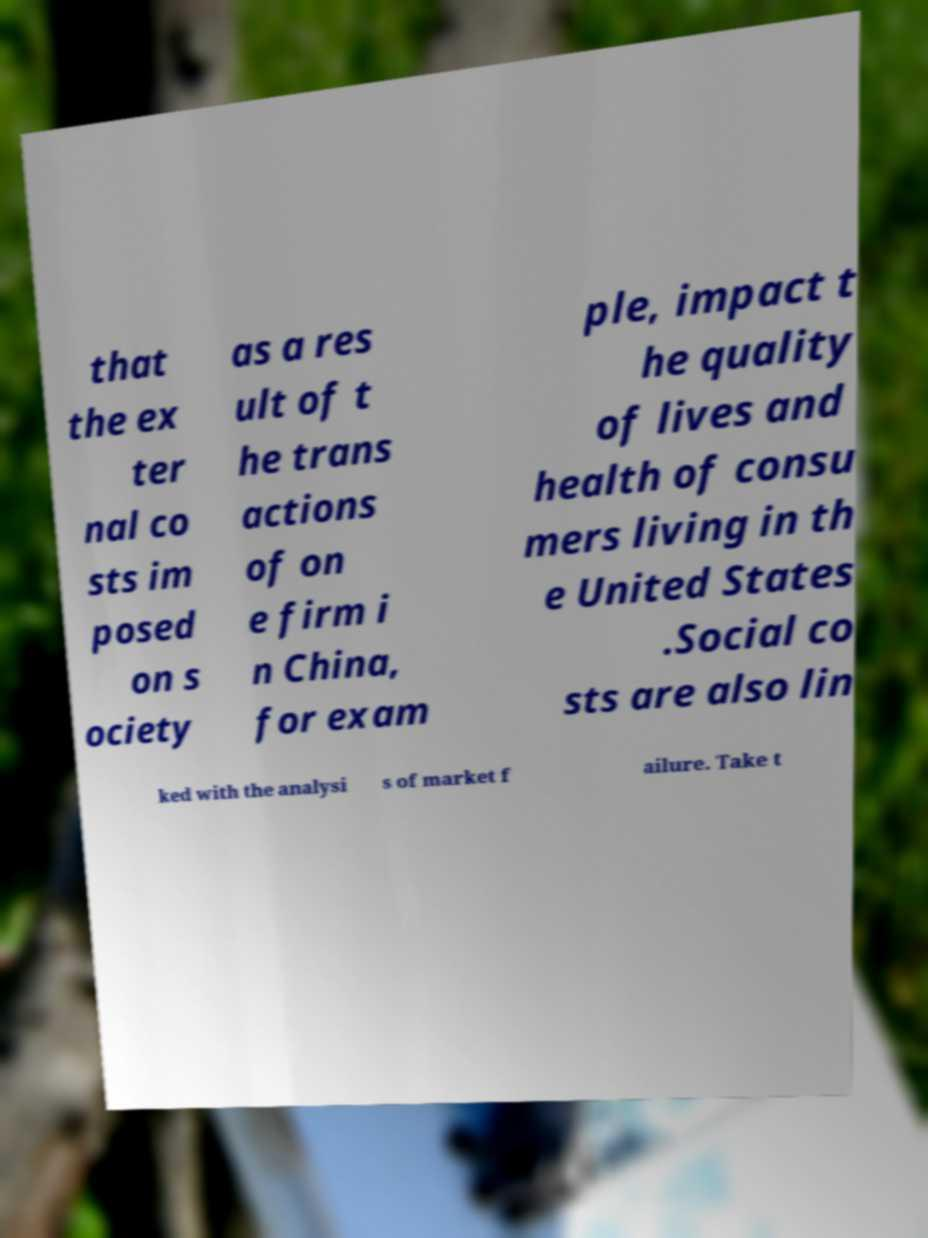Can you read and provide the text displayed in the image?This photo seems to have some interesting text. Can you extract and type it out for me? that the ex ter nal co sts im posed on s ociety as a res ult of t he trans actions of on e firm i n China, for exam ple, impact t he quality of lives and health of consu mers living in th e United States .Social co sts are also lin ked with the analysi s of market f ailure. Take t 